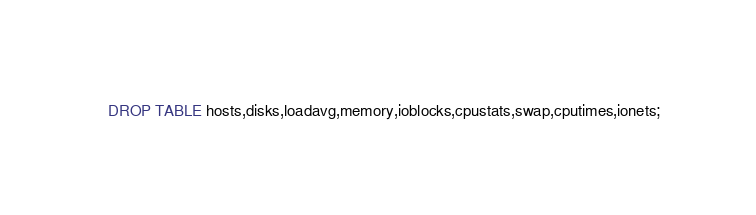Convert code to text. <code><loc_0><loc_0><loc_500><loc_500><_SQL_>DROP TABLE hosts,disks,loadavg,memory,ioblocks,cpustats,swap,cputimes,ionets;</code> 